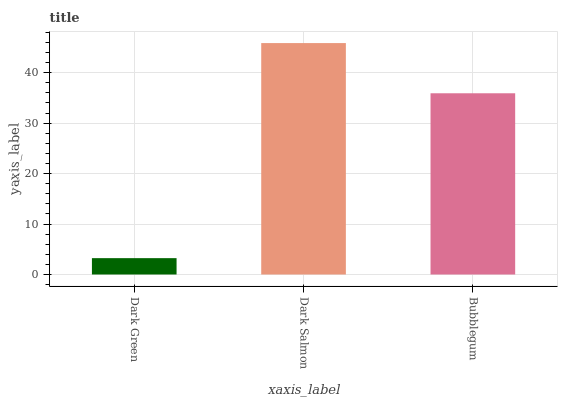Is Dark Green the minimum?
Answer yes or no. Yes. Is Dark Salmon the maximum?
Answer yes or no. Yes. Is Bubblegum the minimum?
Answer yes or no. No. Is Bubblegum the maximum?
Answer yes or no. No. Is Dark Salmon greater than Bubblegum?
Answer yes or no. Yes. Is Bubblegum less than Dark Salmon?
Answer yes or no. Yes. Is Bubblegum greater than Dark Salmon?
Answer yes or no. No. Is Dark Salmon less than Bubblegum?
Answer yes or no. No. Is Bubblegum the high median?
Answer yes or no. Yes. Is Bubblegum the low median?
Answer yes or no. Yes. Is Dark Salmon the high median?
Answer yes or no. No. Is Dark Salmon the low median?
Answer yes or no. No. 